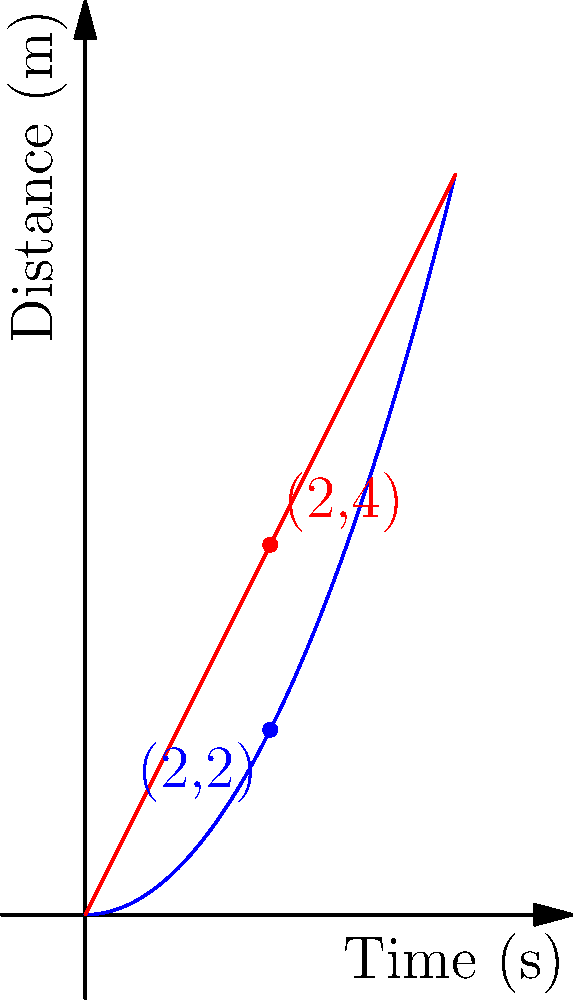A robotic arm is programmed to move from point A to point B using two different trajectories, as shown in the graph. Trajectory A follows the function $y = 0.5x^2$, while Trajectory B follows $y = 2x$. At $t = 2$ seconds, which trajectory results in a more efficient movement in terms of distance covered, and by how much? To determine which trajectory is more efficient at $t = 2$ seconds, we need to compare the distances covered by each trajectory:

1. For Trajectory A ($y = 0.5x^2$):
   At $t = 2$, $y_A = 0.5(2)^2 = 0.5(4) = 2$ meters

2. For Trajectory B ($y = 2x$):
   At $t = 2$, $y_B = 2(2) = 4$ meters

3. Calculate the difference in distance:
   Difference = $y_B - y_A = 4 - 2 = 2$ meters

4. Determine efficiency:
   Trajectory B covers a greater distance (4 meters) compared to Trajectory A (2 meters) at $t = 2$ seconds.

5. Calculate the percentage difference:
   Percentage difference = $\frac{\text{Difference}}{\text{Smaller distance}} \times 100\%$
   $= \frac{2}{2} \times 100\% = 100\%$

Therefore, Trajectory B is more efficient, covering 100% more distance than Trajectory A at $t = 2$ seconds.
Answer: Trajectory B, 100% more efficient 